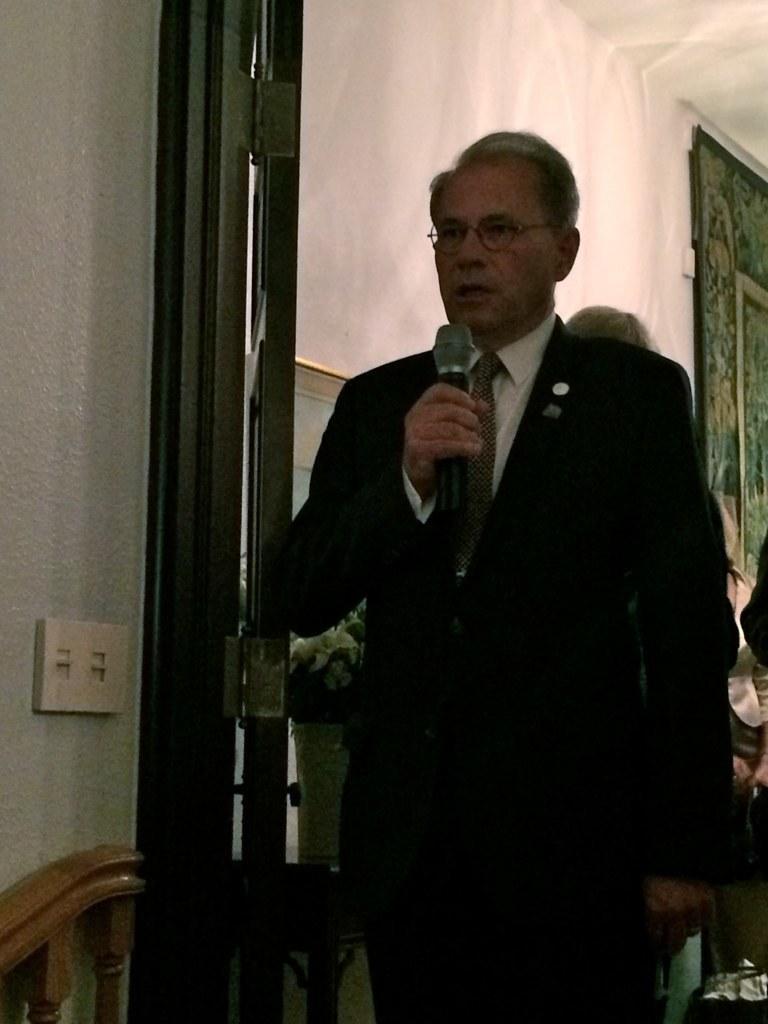In one or two sentences, can you explain what this image depicts? In the foreground of this image, there is a man standing in suit and holding a mic. Beside him, there is a door and a switch board to the wall. In the background, there is a wall, frame and few persons. 